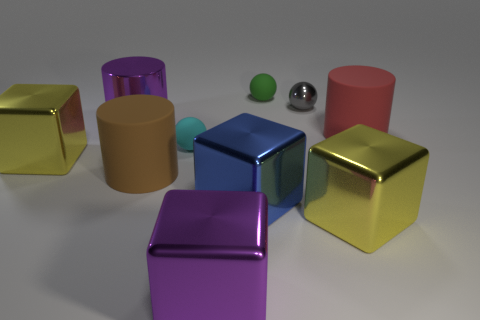What number of blocks are the same color as the metallic cylinder?
Your answer should be very brief. 1. How many big objects are red cylinders or purple metallic blocks?
Your response must be concise. 2. Are the big yellow cube in front of the blue object and the cyan thing made of the same material?
Your answer should be very brief. No. There is a rubber ball behind the purple shiny cylinder; what color is it?
Make the answer very short. Green. Is there a yellow metal block that has the same size as the cyan ball?
Your answer should be compact. No. What material is the red object that is the same size as the brown matte thing?
Offer a terse response. Rubber. There is a purple metal cube; is its size the same as the matte sphere that is in front of the small green rubber object?
Keep it short and to the point. No. There is a block that is behind the big blue cube; what is its material?
Provide a short and direct response. Metal. Are there the same number of large objects right of the blue cube and metallic blocks?
Offer a terse response. No. Does the brown thing have the same size as the gray metal thing?
Make the answer very short. No. 